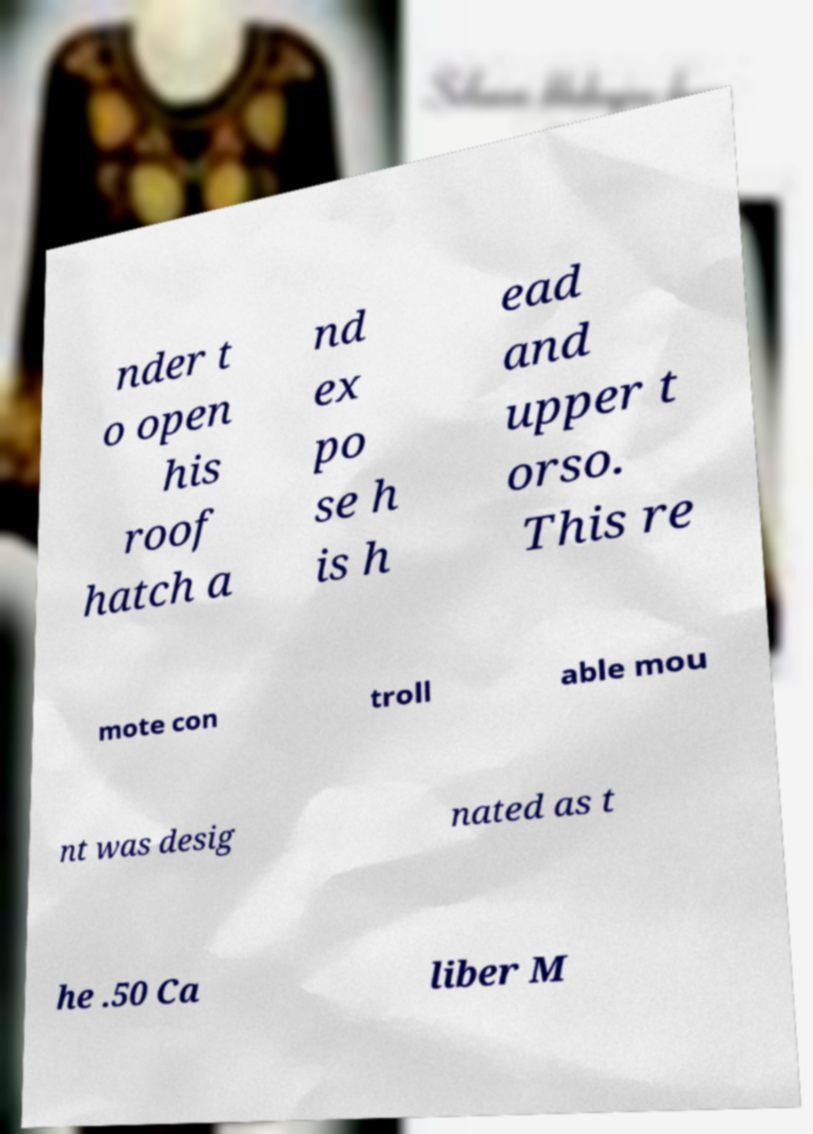I need the written content from this picture converted into text. Can you do that? nder t o open his roof hatch a nd ex po se h is h ead and upper t orso. This re mote con troll able mou nt was desig nated as t he .50 Ca liber M 